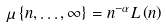Convert formula to latex. <formula><loc_0><loc_0><loc_500><loc_500>\mu \left \{ n , \dots , \infty \right \} = n ^ { - \alpha } L \left ( n \right )</formula> 